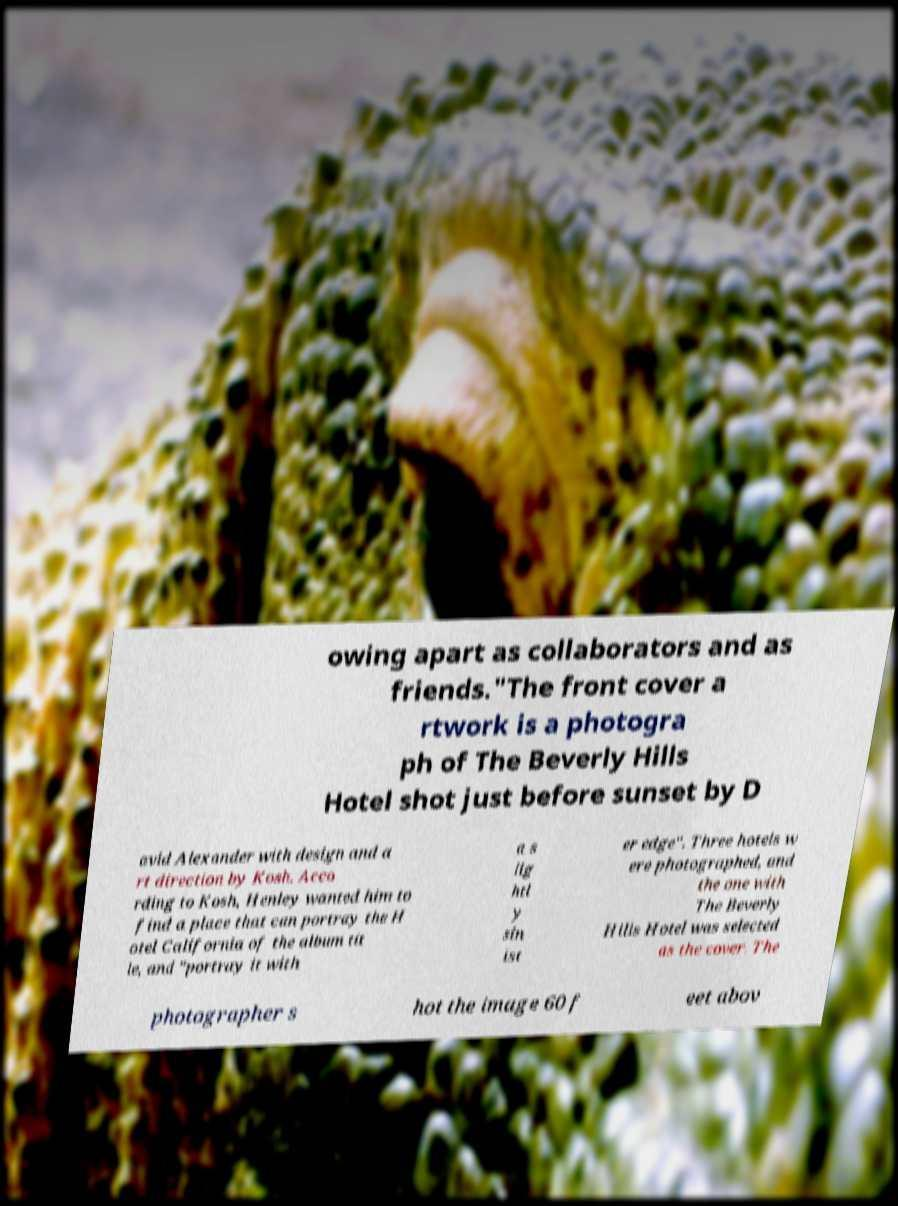Please identify and transcribe the text found in this image. owing apart as collaborators and as friends."The front cover a rtwork is a photogra ph of The Beverly Hills Hotel shot just before sunset by D avid Alexander with design and a rt direction by Kosh. Acco rding to Kosh, Henley wanted him to find a place that can portray the H otel California of the album tit le, and "portray it with a s lig htl y sin ist er edge". Three hotels w ere photographed, and the one with The Beverly Hills Hotel was selected as the cover. The photographer s hot the image 60 f eet abov 